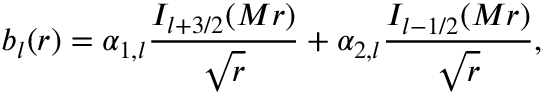<formula> <loc_0><loc_0><loc_500><loc_500>b _ { l } ( r ) = \alpha _ { 1 , l } { \frac { I _ { l + 3 / 2 } ( M r ) } { \sqrt { r } } } + \alpha _ { 2 , l } { \frac { I _ { l - 1 / 2 } ( M r ) } { \sqrt { r } } } ,</formula> 